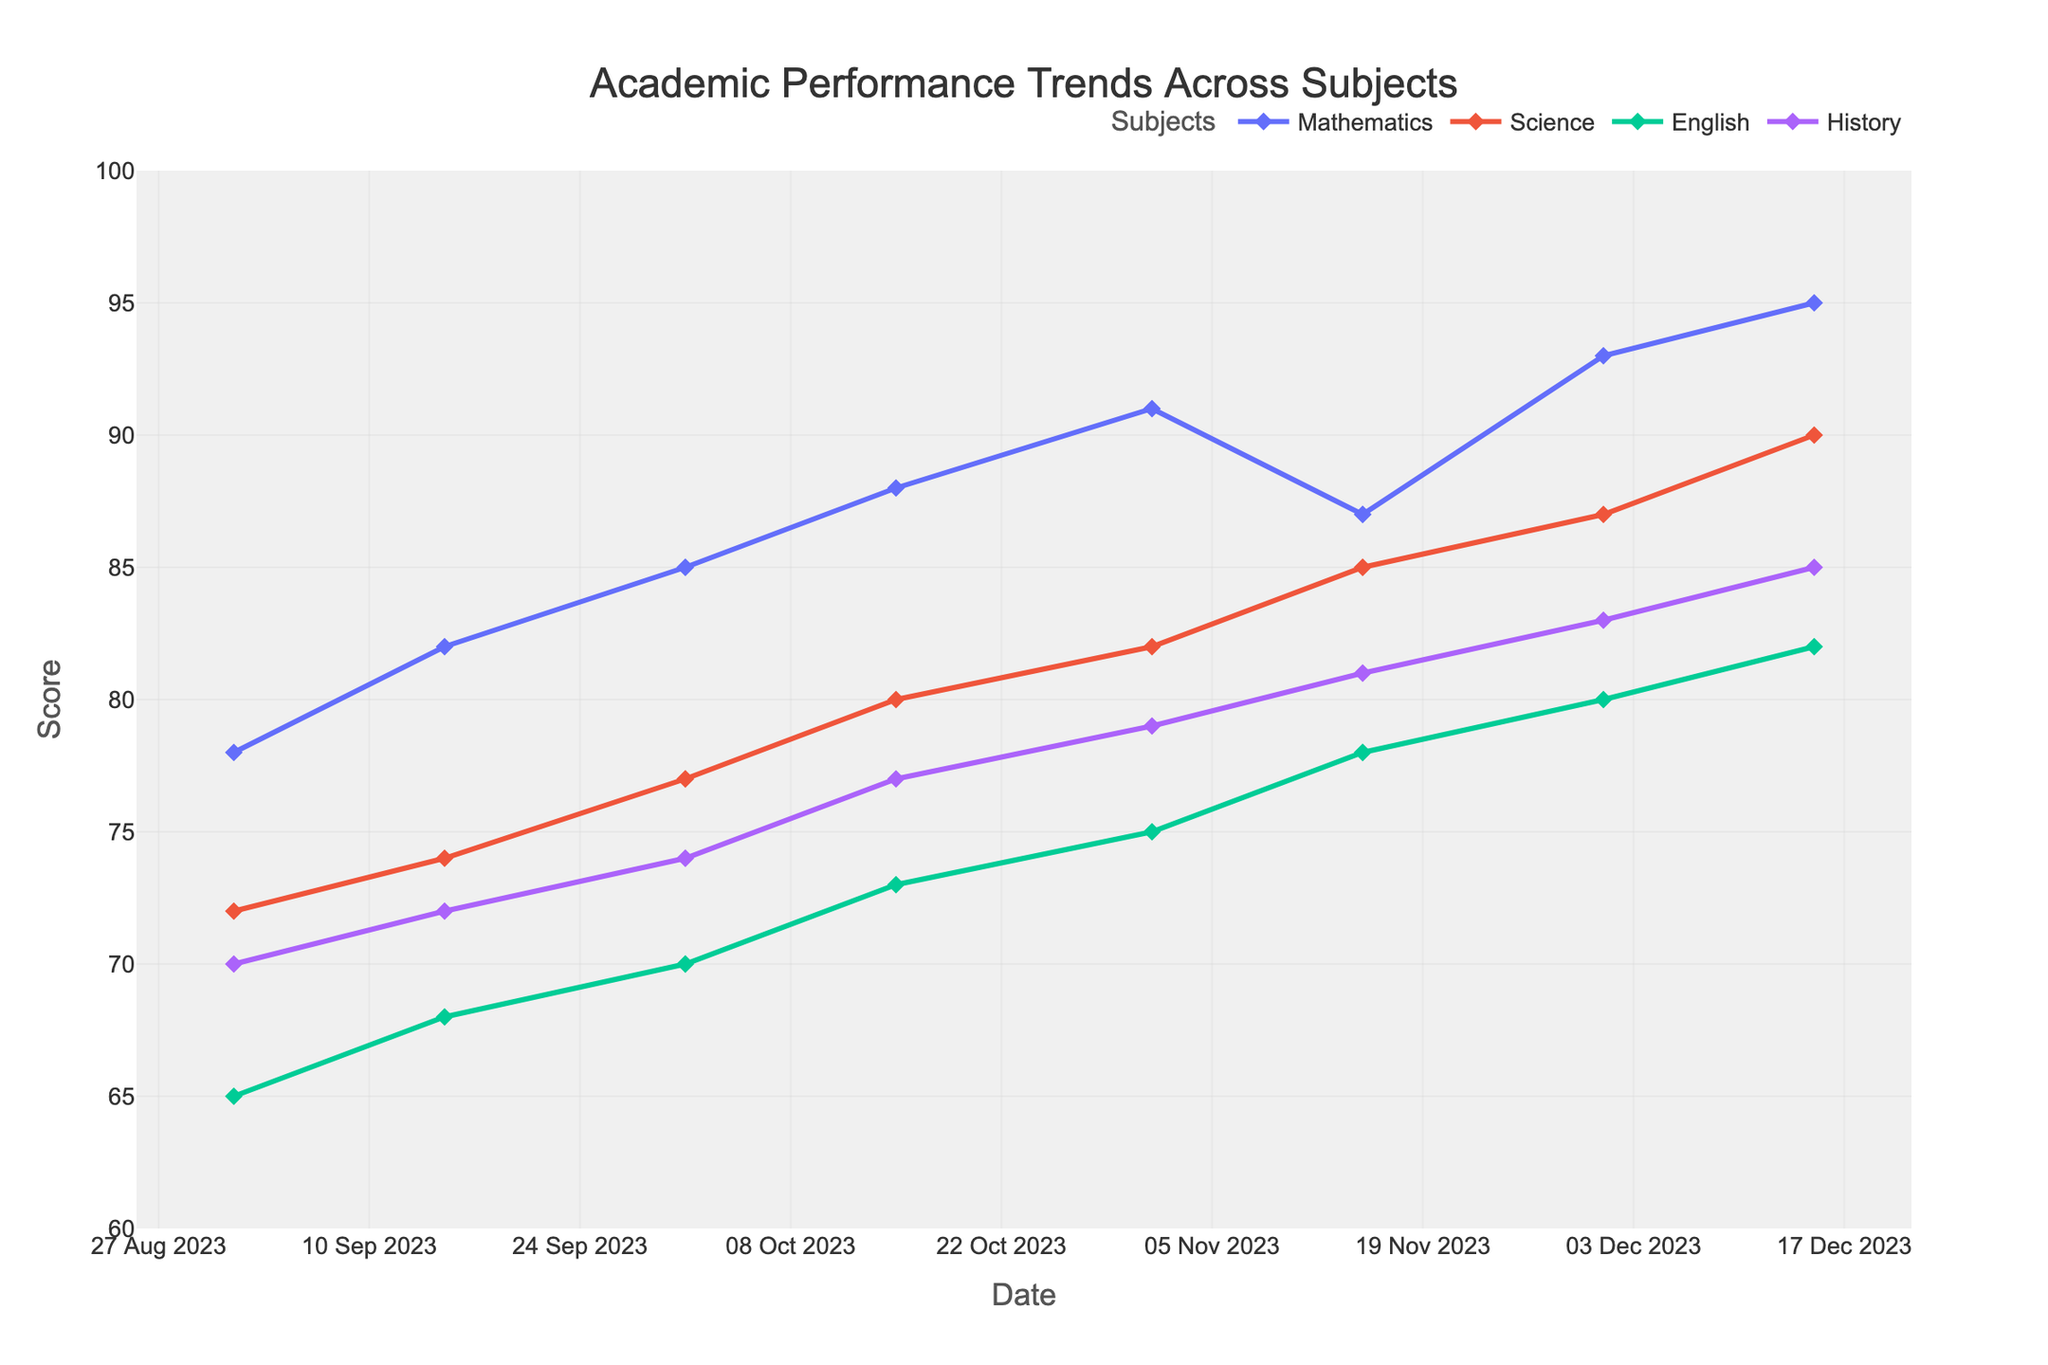What is the title of the plot? The title is displayed prominently at the top of the figure. It provides a summary of what the graph represents.
Answer: Academic Performance Trends Across Subjects How many subjects are tracked in the plot? By looking at the legend, we can see the distinct subjects listed, each represented by a unique color/marker.
Answer: 4 What date range does the plot cover? The x-axis labels show the timeline from the start to the end of the data.
Answer: 01 Sep 2023 to 15 Dec 2023 Which subject shows the highest final score at the end of the semester? By examining the scores on the last date (15 Dec 2023) for all subjects, we can observe which line reaches the highest point.
Answer: Mathematics Did the Science scores ever exceed Mathematics scores at any point in the semester? We need to compare the scores for Science and Mathematics across all dates; Science scores should be consistently lower or equal if Mathematics is always higher.
Answer: No What is the difference between the highest and lowest final scores across all subjects on 15 Dec 2023? To find this, look at the scores of all subjects on 15 Dec 2023, identify the highest and lowest scores, and calculate their difference.
Answer: 95 - 82 = 13 How many times did the score for English increase throughout the semester? Review the score trend for English at each data point and count the increments.
Answer: 7 Which subject had the steepest increase in scores over the semester? Calculate the total score increase for each subject from the beginning to the end of the semester, and compare the differences.
Answer: Science (18 points increase) On which date did Mathematics scores experience a decline, and what was the change in score? Check the line for Mathematics and identify the point(s) where the score drops from one date to the next, then note the date and score change.
Answer: 15 Nov 2023, a decrease from 91 to 87 What is the average score of all subjects on 01 Nov 2023? Collect the scores for all subjects on 01 Nov 2023, sum them, and divide by the number of subjects to get the average.
Answer: (91 + 82 + 75 + 79) / 4 = 81.75 